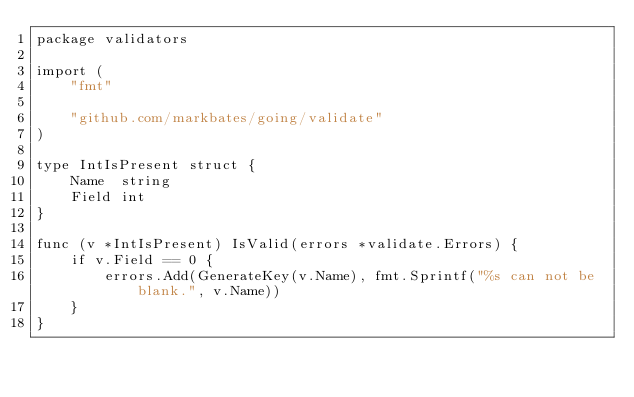<code> <loc_0><loc_0><loc_500><loc_500><_Go_>package validators

import (
	"fmt"

	"github.com/markbates/going/validate"
)

type IntIsPresent struct {
	Name  string
	Field int
}

func (v *IntIsPresent) IsValid(errors *validate.Errors) {
	if v.Field == 0 {
		errors.Add(GenerateKey(v.Name), fmt.Sprintf("%s can not be blank.", v.Name))
	}
}
</code> 